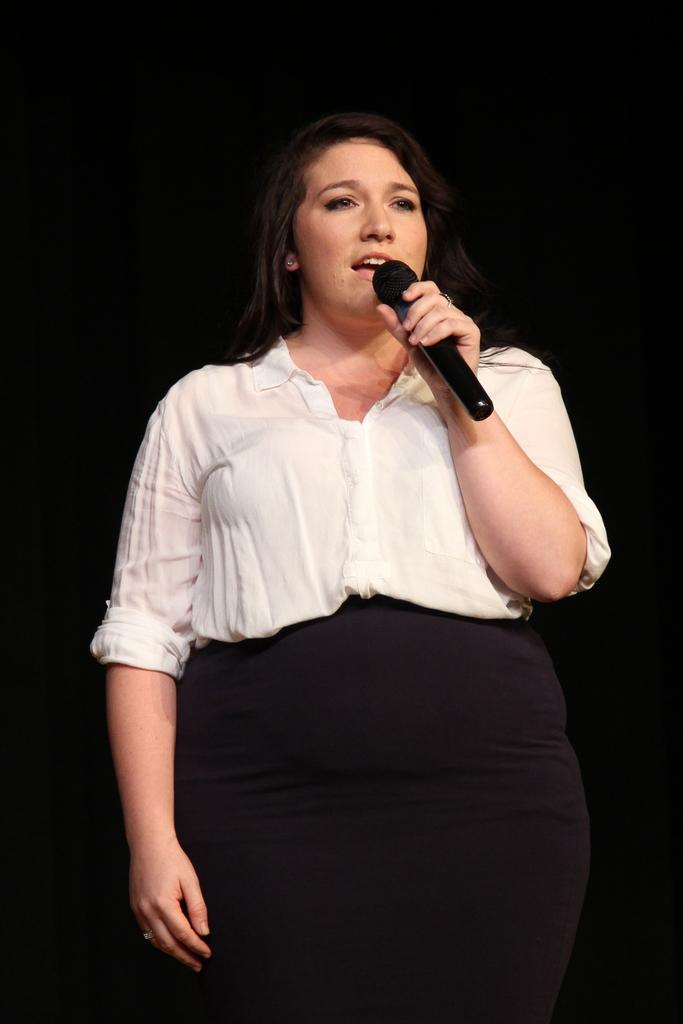What is the main subject of the image? The main subject of the image is a woman. What is the woman doing in the image? The woman is standing in the image. What object is the woman holding in the image? The woman is holding a mic in the image. What type of jelly can be seen on the woman's face in the image? There is no jelly present on the woman's face in the image. How many flies can be seen buzzing around the woman in the image? There are no flies present around the woman in the image. 